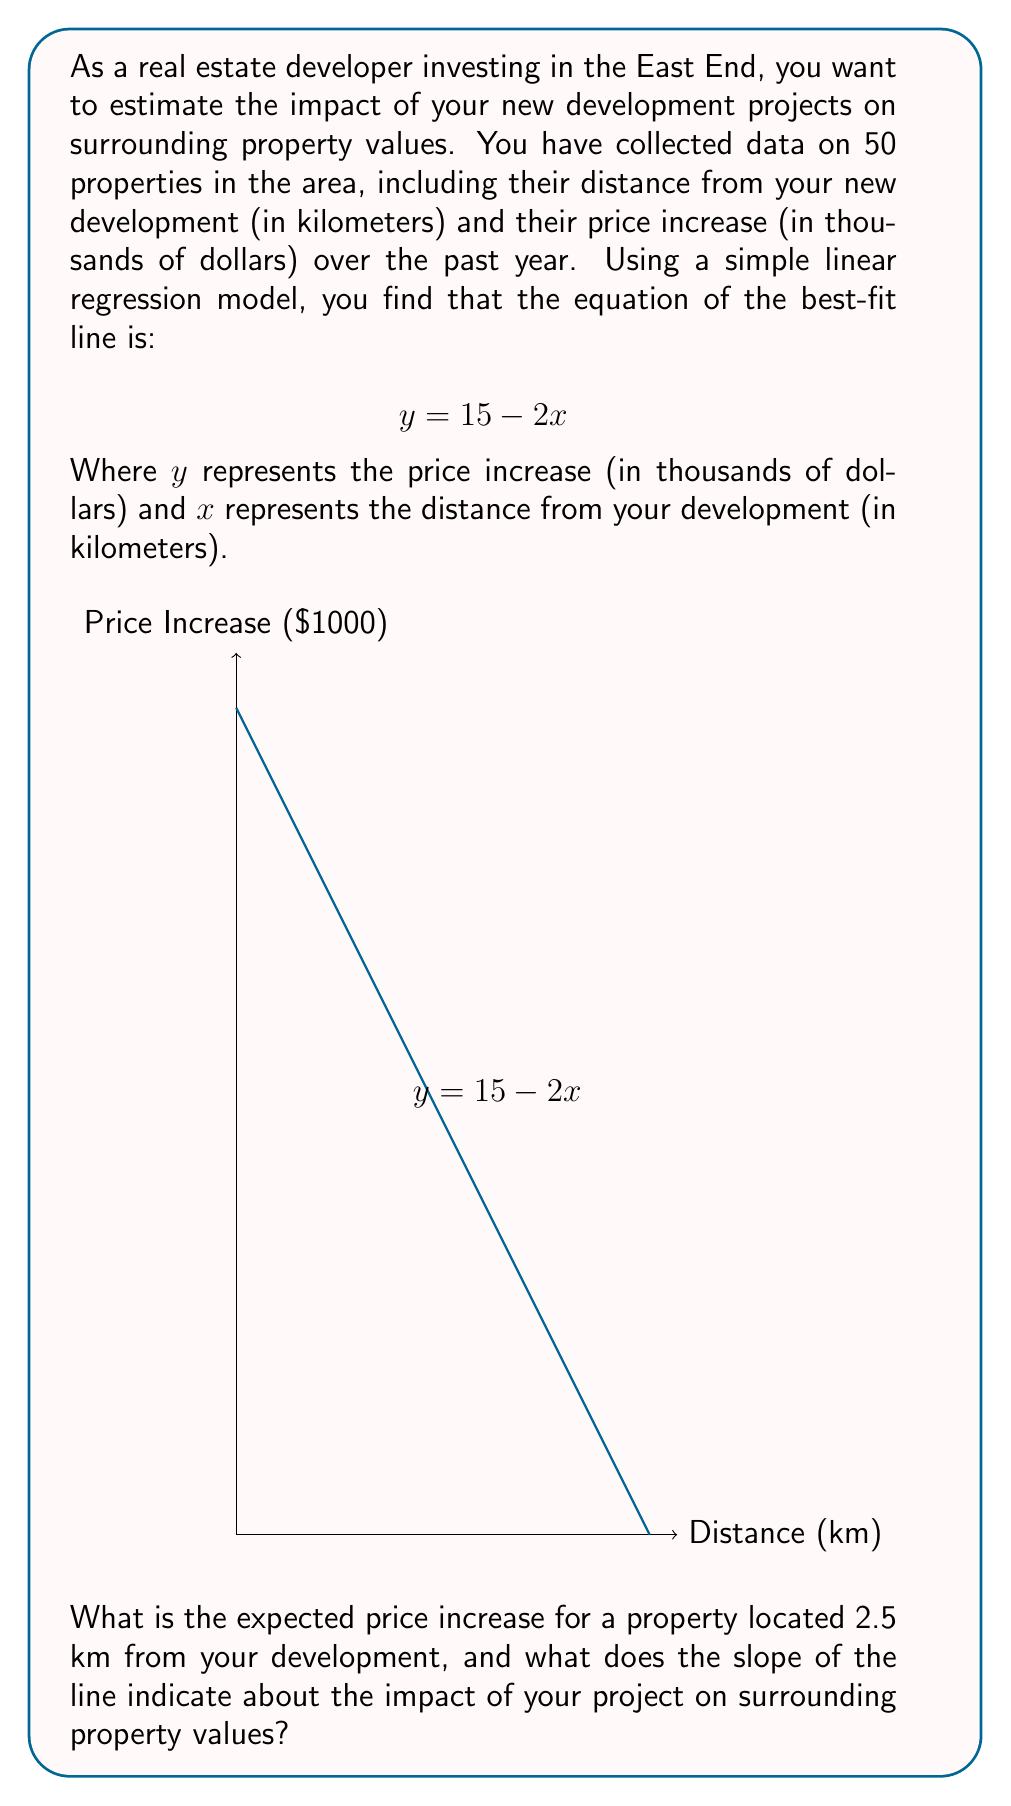Help me with this question. To solve this problem, we'll follow these steps:

1) First, let's calculate the expected price increase for a property 2.5 km from the development:
   
   We use the equation $y = 15 - 2x$, where $x = 2.5$
   
   $$y = 15 - 2(2.5) = 15 - 5 = 10$$

   So, the expected price increase is $10,000.

2) Now, let's interpret the slope of the line:
   
   In the equation $y = 15 - 2x$, the slope is -2.
   
   This means that for every 1 km increase in distance from the development, the price increase decreases by $2,000.

3) Interpreting the impact:
   
   The negative slope indicates that properties closer to the development experience larger price increases.
   
   Specifically, for every kilometer closer to the development, property values are expected to increase by an additional $2,000.

This suggests that your development project has a positive impact on surrounding property values, with the impact decreasing as distance from the development increases.
Answer: $10,000 increase; -$2,000/km impact 